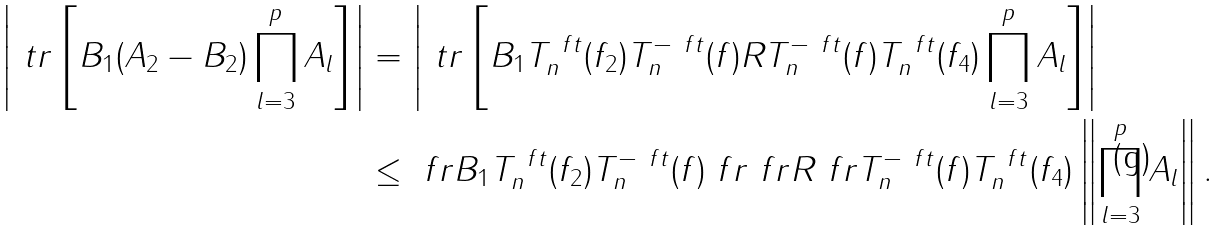Convert formula to latex. <formula><loc_0><loc_0><loc_500><loc_500>\left | \ t r \left [ B _ { 1 } ( A _ { 2 } - B _ { 2 } ) \prod _ { l = 3 } ^ { p } A _ { l } \right ] \right | & = \left | \ t r \left [ B _ { 1 } T _ { n } ^ { \ f t } ( f _ { 2 } ) T _ { n } ^ { - \ f t } ( f ) R T _ { n } ^ { - \ f t } ( f ) T _ { n } ^ { \ f t } ( f _ { 4 } ) \prod _ { l = 3 } ^ { p } A _ { l } \right ] \right | \\ & \leq \ f r B _ { 1 } T _ { n } ^ { \ f t } ( f _ { 2 } ) T _ { n } ^ { - \ f t } ( f ) \ f r \ f r R \ f r \| T _ { n } ^ { - \ f t } ( f ) T _ { n } ^ { \ f t } ( f _ { 4 } ) \| \left \| \prod _ { l = 3 } ^ { p } A _ { l } \right \| .</formula> 